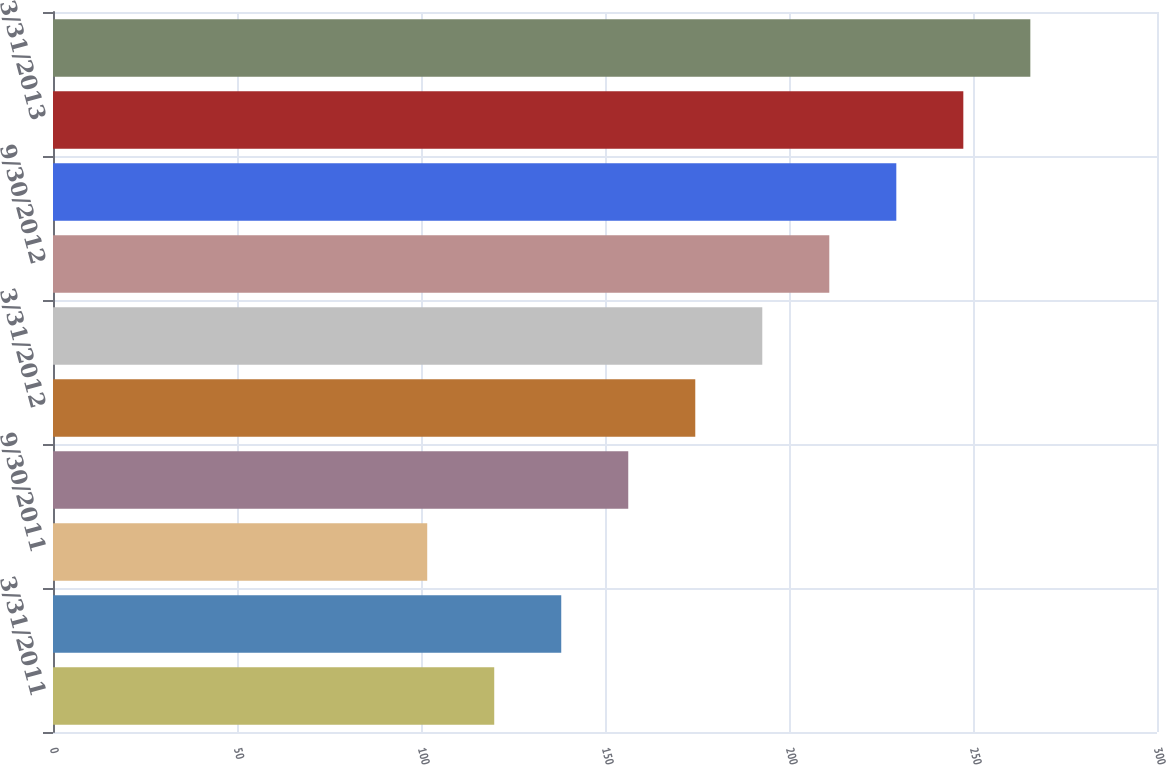Convert chart. <chart><loc_0><loc_0><loc_500><loc_500><bar_chart><fcel>3/31/2011<fcel>6/30/2011<fcel>9/30/2011<fcel>12/31/2011<fcel>3/31/2012<fcel>6/30/2012<fcel>9/30/2012<fcel>12/31/2012<fcel>3/31/2013<fcel>6/30/2013<nl><fcel>119.9<fcel>138.11<fcel>101.69<fcel>156.32<fcel>174.53<fcel>192.74<fcel>210.95<fcel>229.16<fcel>247.37<fcel>265.58<nl></chart> 